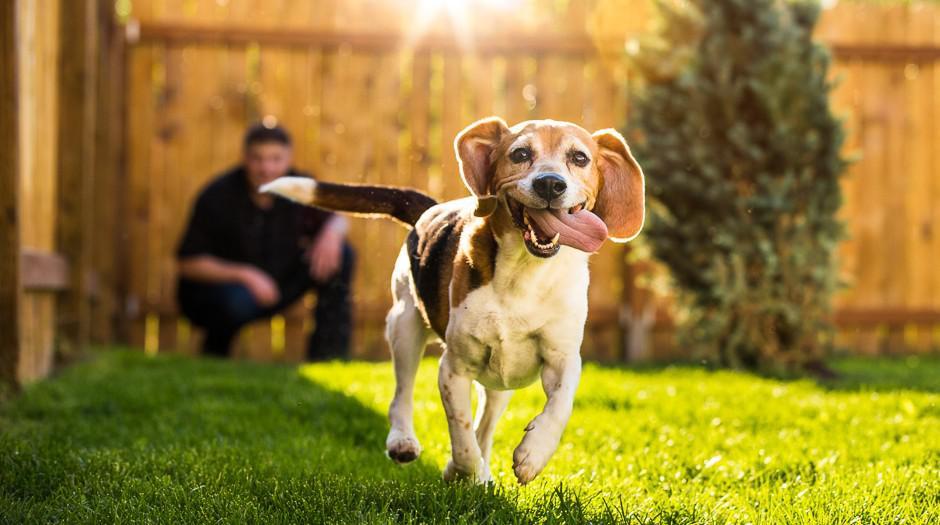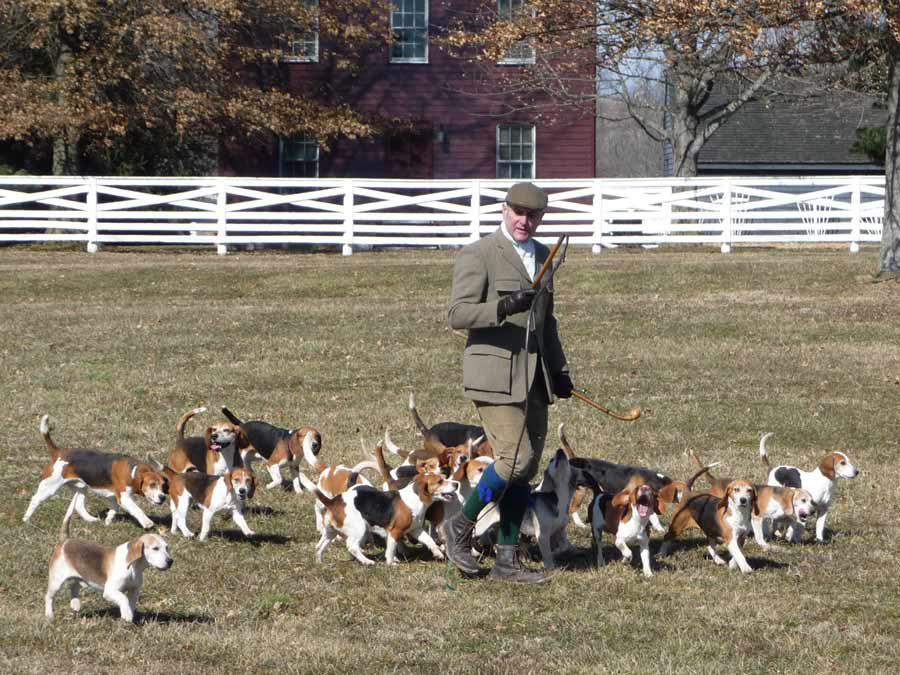The first image is the image on the left, the second image is the image on the right. Examine the images to the left and right. Is the description "An image shows two people wearing white trousers standing by a pack of hound dogs." accurate? Answer yes or no. No. The first image is the image on the left, the second image is the image on the right. Evaluate the accuracy of this statement regarding the images: "In one image, two people wearing white pants and dark tops, and carrying dog handling equipment are standing with a pack of dogs.". Is it true? Answer yes or no. No. 